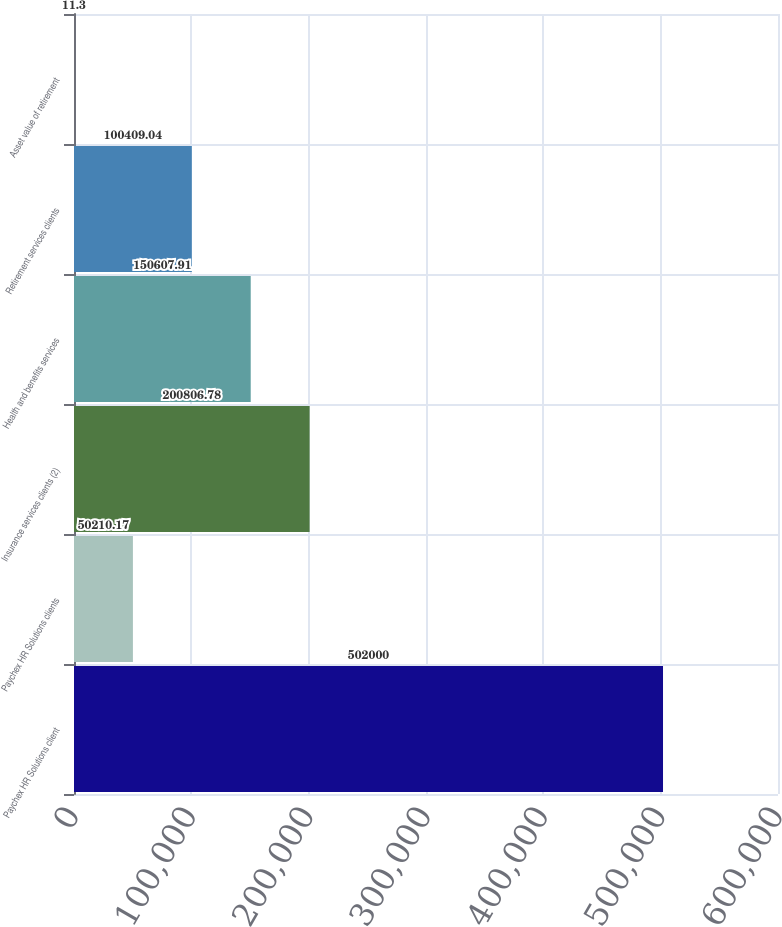<chart> <loc_0><loc_0><loc_500><loc_500><bar_chart><fcel>Paychex HR Solutions client<fcel>Paychex HR Solutions clients<fcel>Insurance services clients (2)<fcel>Health and benefits services<fcel>Retirement services clients<fcel>Asset value of retirement<nl><fcel>502000<fcel>50210.2<fcel>200807<fcel>150608<fcel>100409<fcel>11.3<nl></chart> 